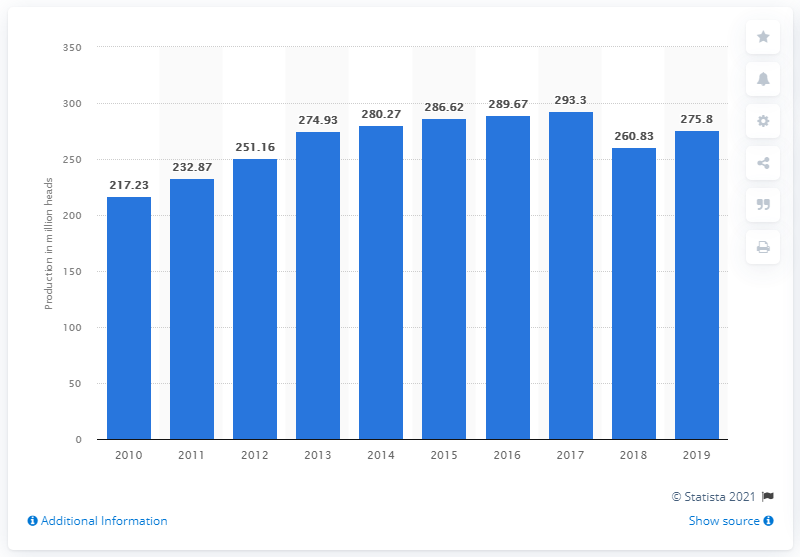List a handful of essential elements in this visual. In 2019, a total of 275.8 million chickens were produced in Malaysia. 